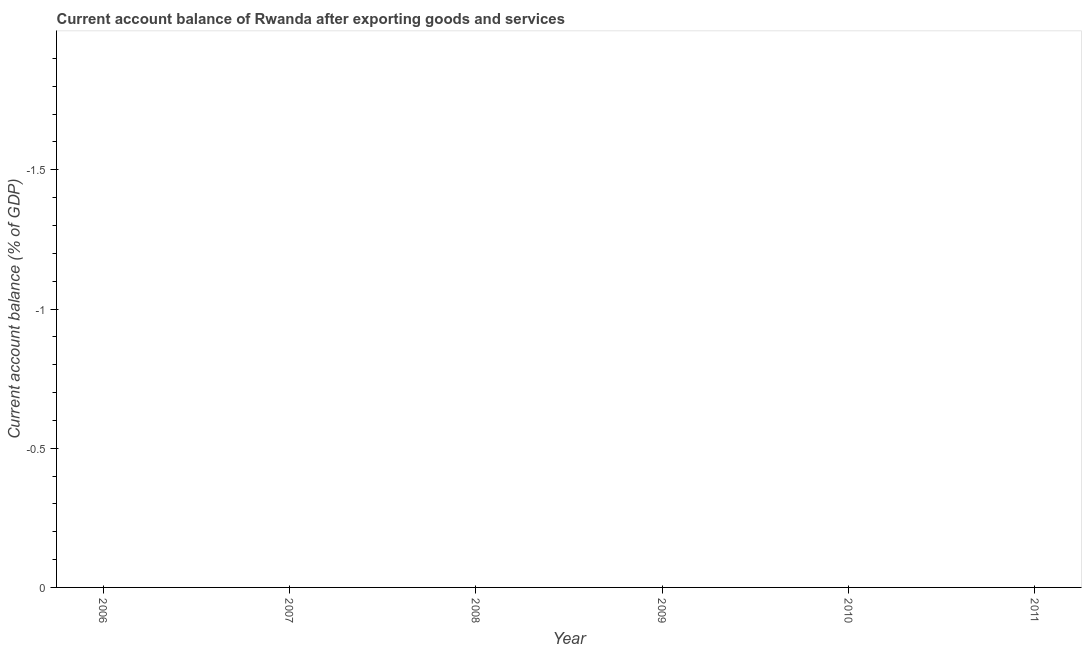Across all years, what is the minimum current account balance?
Keep it short and to the point. 0. What is the sum of the current account balance?
Offer a terse response. 0. What is the average current account balance per year?
Give a very brief answer. 0. Does the current account balance monotonically increase over the years?
Offer a terse response. No. How many lines are there?
Ensure brevity in your answer.  0. How many years are there in the graph?
Offer a terse response. 6. What is the difference between two consecutive major ticks on the Y-axis?
Your answer should be very brief. 0.5. Are the values on the major ticks of Y-axis written in scientific E-notation?
Offer a terse response. No. Does the graph contain any zero values?
Make the answer very short. Yes. What is the title of the graph?
Your response must be concise. Current account balance of Rwanda after exporting goods and services. What is the label or title of the X-axis?
Keep it short and to the point. Year. What is the label or title of the Y-axis?
Offer a very short reply. Current account balance (% of GDP). What is the Current account balance (% of GDP) in 2006?
Provide a short and direct response. 0. What is the Current account balance (% of GDP) in 2009?
Give a very brief answer. 0. What is the Current account balance (% of GDP) in 2011?
Keep it short and to the point. 0. 